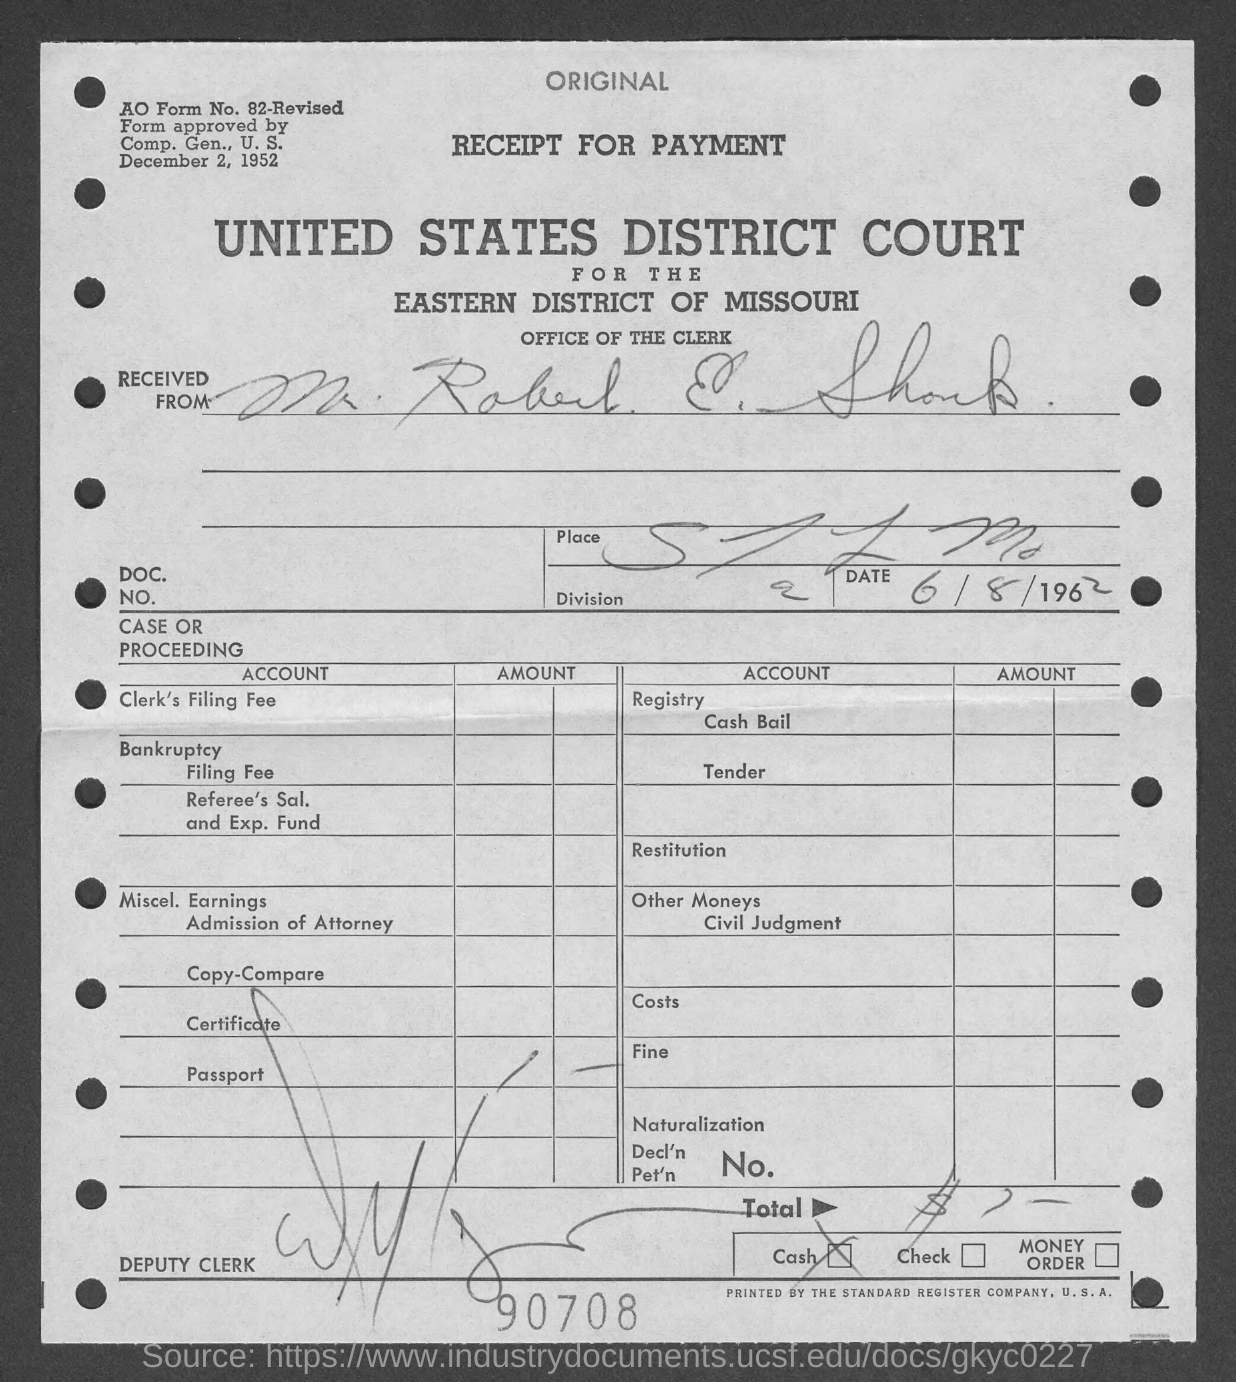What is the number at bottom of the page ?
Offer a very short reply. 90708. 